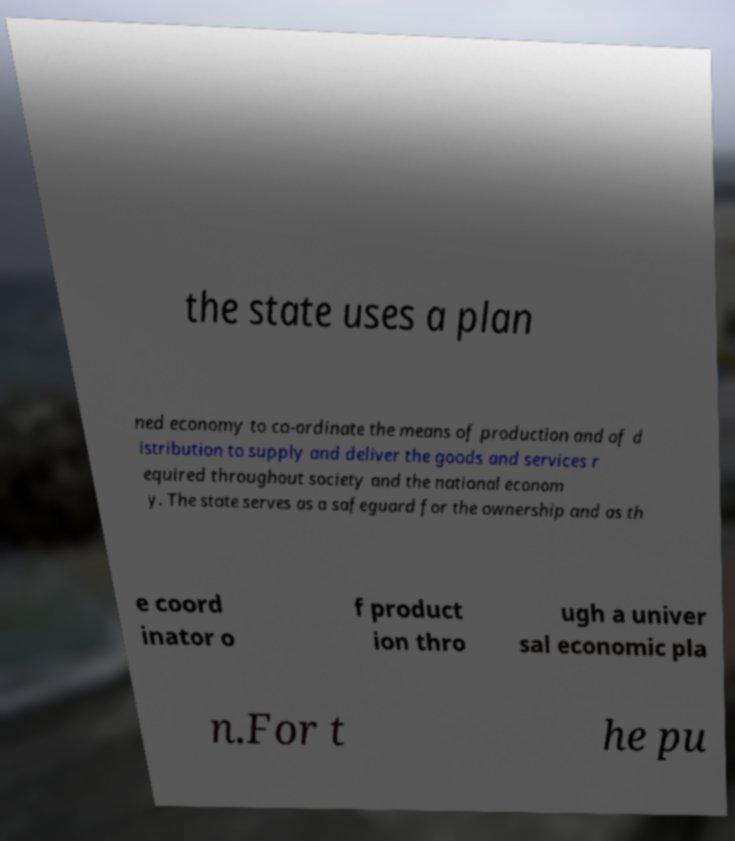I need the written content from this picture converted into text. Can you do that? the state uses a plan ned economy to co-ordinate the means of production and of d istribution to supply and deliver the goods and services r equired throughout society and the national econom y. The state serves as a safeguard for the ownership and as th e coord inator o f product ion thro ugh a univer sal economic pla n.For t he pu 